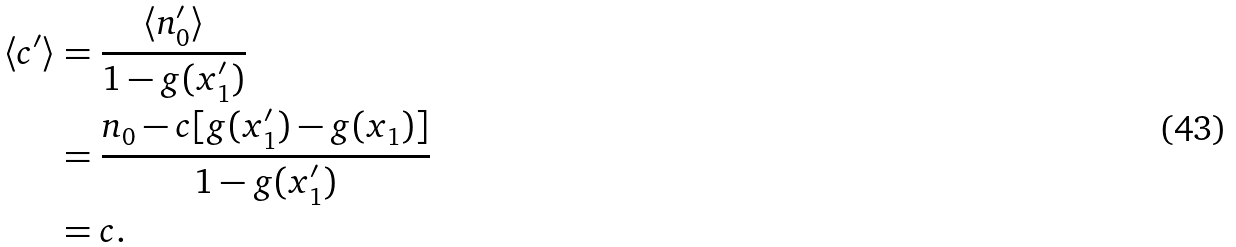Convert formula to latex. <formula><loc_0><loc_0><loc_500><loc_500>\langle c ^ { \prime } \rangle & = \frac { \langle n ^ { \prime } _ { 0 } \rangle } { 1 - g ( x ^ { \prime } _ { 1 } ) } \\ & = \frac { n _ { 0 } - c [ g ( x ^ { \prime } _ { 1 } ) - g ( x _ { 1 } ) ] } { 1 - g ( x ^ { \prime } _ { 1 } ) } \\ & = c .</formula> 